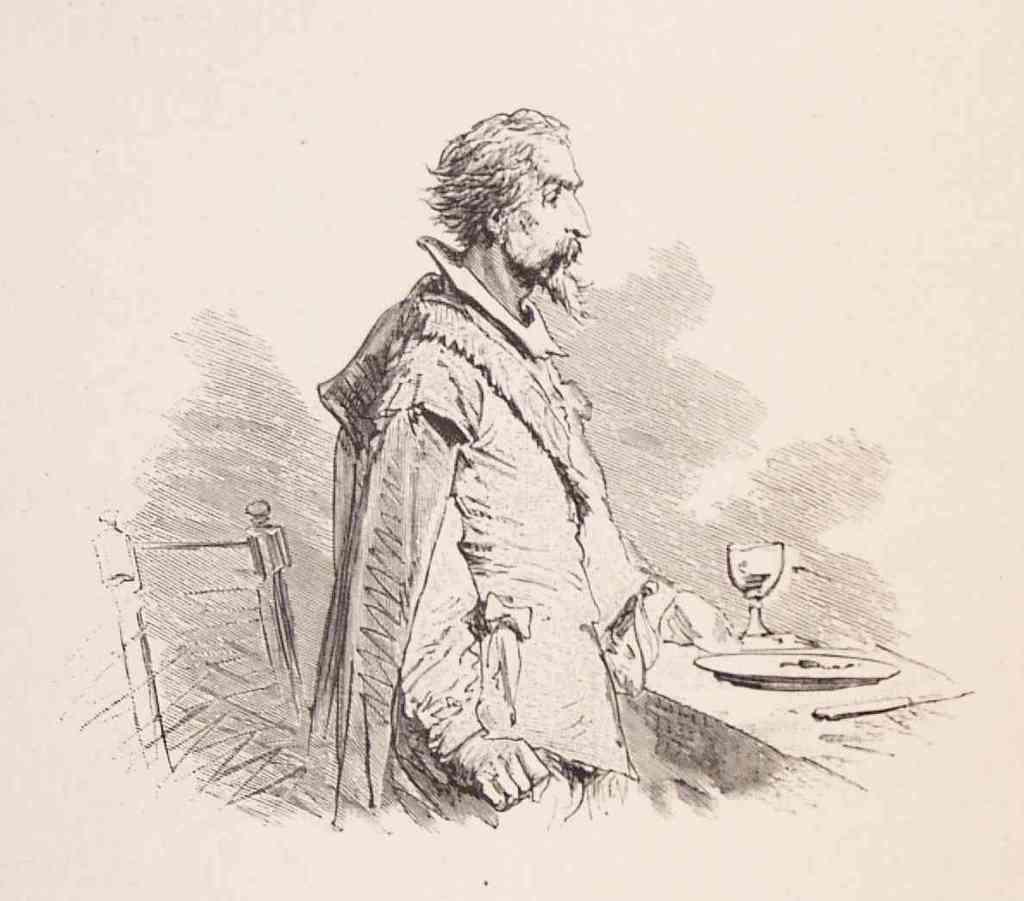Could you give a brief overview of what you see in this image? This is a sketch of a man holding a plate, a knife and a glass in his hand and there is a chair. 